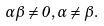Convert formula to latex. <formula><loc_0><loc_0><loc_500><loc_500>\alpha \beta \neq 0 , \alpha \neq \beta .</formula> 